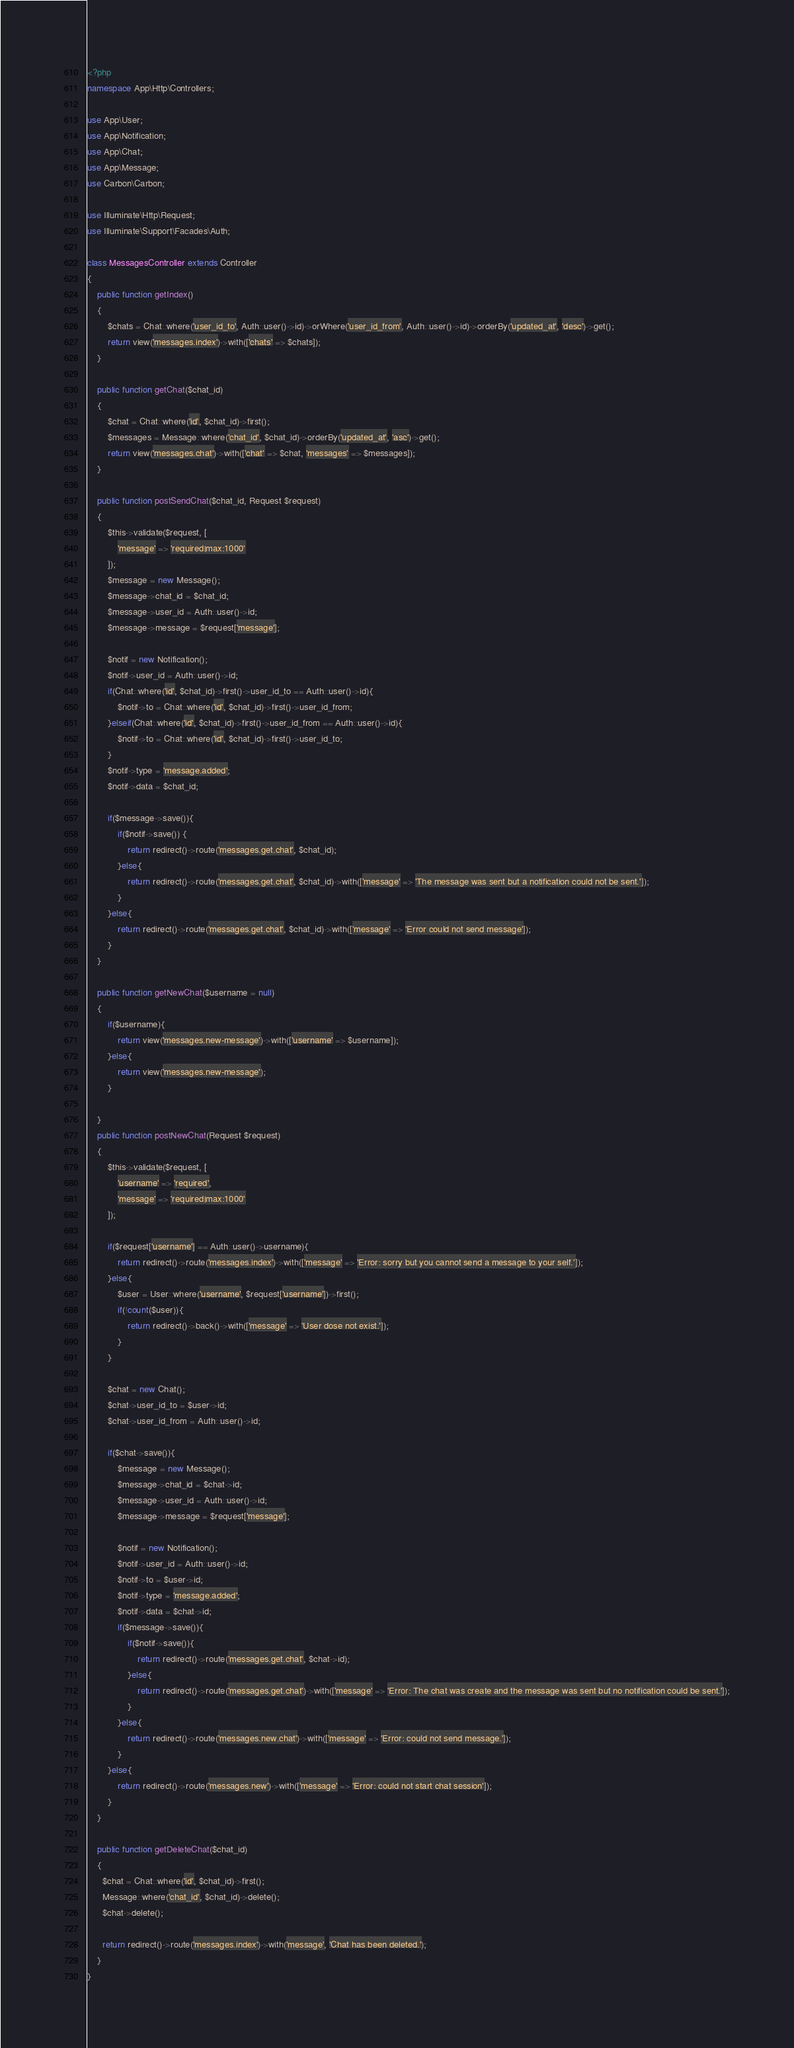Convert code to text. <code><loc_0><loc_0><loc_500><loc_500><_PHP_><?php
namespace App\Http\Controllers;

use App\User;
use App\Notification;
use App\Chat;
use App\Message;
use Carbon\Carbon;

use Illuminate\Http\Request;
use Illuminate\Support\Facades\Auth;

class MessagesController extends Controller
{
    public function getIndex()
    {
        $chats = Chat::where('user_id_to', Auth::user()->id)->orWhere('user_id_from', Auth::user()->id)->orderBy('updated_at', 'desc')->get();
        return view('messages.index')->with(['chats' => $chats]);
    }

    public function getChat($chat_id)
    {
        $chat = Chat::where('id', $chat_id)->first();
        $messages = Message::where('chat_id', $chat_id)->orderBy('updated_at', 'asc')->get();
        return view('messages.chat')->with(['chat' => $chat, 'messages' => $messages]);
    }

    public function postSendChat($chat_id, Request $request)
    {
        $this->validate($request, [
            'message' => 'required|max:1000'
        ]);
        $message = new Message();
        $message->chat_id = $chat_id;
        $message->user_id = Auth::user()->id;
        $message->message = $request['message'];

        $notif = new Notification();
        $notif->user_id = Auth::user()->id;
        if(Chat::where('id', $chat_id)->first()->user_id_to == Auth::user()->id){
            $notif->to = Chat::where('id', $chat_id)->first()->user_id_from;
        }elseif(Chat::where('id', $chat_id)->first()->user_id_from == Auth::user()->id){
            $notif->to = Chat::where('id', $chat_id)->first()->user_id_to;
        }
        $notif->type = 'message.added';
        $notif->data = $chat_id;

        if($message->save()){
            if($notif->save()) {
                return redirect()->route('messages.get.chat', $chat_id);
            }else{
                return redirect()->route('messages.get.chat', $chat_id)->with(['message' => 'The message was sent but a notification could not be sent.']);
            }
        }else{
            return redirect()->route('messages.get.chat', $chat_id)->with(['message' => 'Error could not send message']);
        }
    }

    public function getNewChat($username = null)
    {
        if($username){
            return view('messages.new-message')->with(['username' => $username]);
        }else{
            return view('messages.new-message');
        }

    }
    public function postNewChat(Request $request)
    {
        $this->validate($request, [
            'username' => 'required',
            'message' => 'required|max:1000'
        ]);

        if($request['username'] == Auth::user()->username){
            return redirect()->route('messages.index')->with(['message' => 'Error: sorry but you cannot send a message to your self.']);
        }else{
            $user = User::where('username', $request['username'])->first();
            if(!count($user)){
                return redirect()->back()->with(['message' => 'User dose not exist.']);
            }
        }

        $chat = new Chat();
        $chat->user_id_to = $user->id;
        $chat->user_id_from = Auth::user()->id;

        if($chat->save()){
            $message = new Message();
            $message->chat_id = $chat->id;
            $message->user_id = Auth::user()->id;
            $message->message = $request['message'];

            $notif = new Notification();
            $notif->user_id = Auth::user()->id;
            $notif->to = $user->id;
            $notif->type = 'message.added';
            $notif->data = $chat->id;
            if($message->save()){
                if($notif->save()){
                    return redirect()->route('messages.get.chat', $chat->id);
                }else{
                    return redirect()->route('messages.get.chat')->with(['message' => 'Error: The chat was create and the message was sent but no notification could be sent.']);
                }
            }else{
                return redirect()->route('messages.new.chat')->with(['message' => 'Error: could not send message.']);
            }
        }else{
            return redirect()->route('messages.new')->with(['message' => 'Error: could not start chat session']);
        }
    }

    public function getDeleteChat($chat_id)
    {
      $chat = Chat::where('id', $chat_id)->first();
      Message::where('chat_id', $chat_id)->delete();
      $chat->delete();

      return redirect()->route('messages.index')->with('message', 'Chat has been deleted.');
    }
}
</code> 